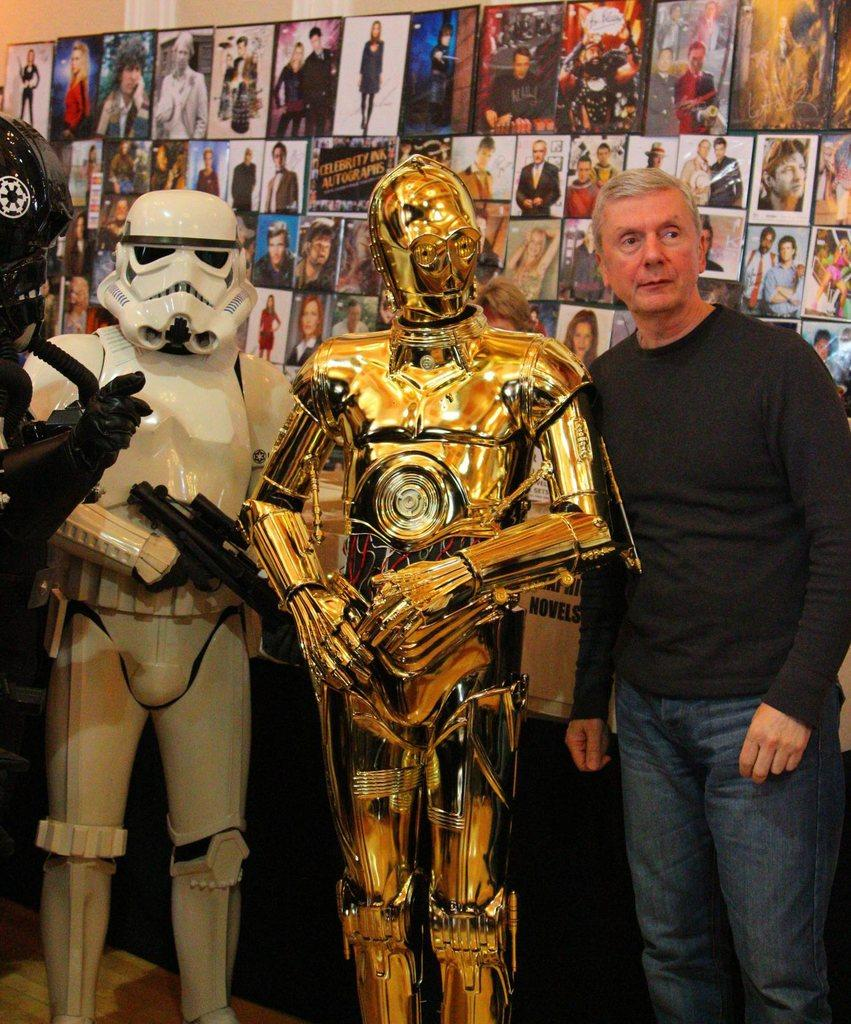What can be seen on the left side of the image? There are three toy robots on the left side of the image. Who is present in the image? There is a man in the image. What is the man wearing? The man is wearing a t-shirt and trousers. What is the man doing in the image? The man is standing. What can be seen in the background of the image? There are many photo frames and a wall in the background of the image. What type of carriage can be seen in the image? There is no carriage present in the image. What color is the flag on the sidewalk in the image? There is no flag or sidewalk present in the image. 